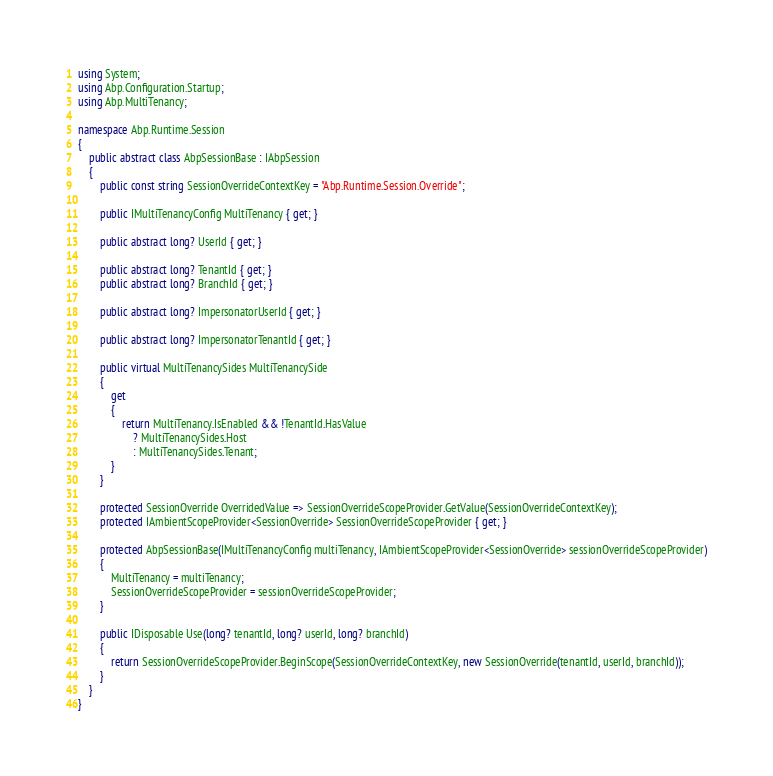<code> <loc_0><loc_0><loc_500><loc_500><_C#_>using System;
using Abp.Configuration.Startup;
using Abp.MultiTenancy;

namespace Abp.Runtime.Session
{
    public abstract class AbpSessionBase : IAbpSession
    {
        public const string SessionOverrideContextKey = "Abp.Runtime.Session.Override";

        public IMultiTenancyConfig MultiTenancy { get; }

        public abstract long? UserId { get; }

        public abstract long? TenantId { get; }
        public abstract long? BranchId { get; }

        public abstract long? ImpersonatorUserId { get; }

        public abstract long? ImpersonatorTenantId { get; }

        public virtual MultiTenancySides MultiTenancySide
        {
            get
            {
                return MultiTenancy.IsEnabled && !TenantId.HasValue
                    ? MultiTenancySides.Host
                    : MultiTenancySides.Tenant;
            }
        }

        protected SessionOverride OverridedValue => SessionOverrideScopeProvider.GetValue(SessionOverrideContextKey);
        protected IAmbientScopeProvider<SessionOverride> SessionOverrideScopeProvider { get; }

        protected AbpSessionBase(IMultiTenancyConfig multiTenancy, IAmbientScopeProvider<SessionOverride> sessionOverrideScopeProvider)
        {
            MultiTenancy = multiTenancy;
            SessionOverrideScopeProvider = sessionOverrideScopeProvider;
        }

        public IDisposable Use(long? tenantId, long? userId, long? branchId)
        {
            return SessionOverrideScopeProvider.BeginScope(SessionOverrideContextKey, new SessionOverride(tenantId, userId, branchId));
        }
    }
}</code> 